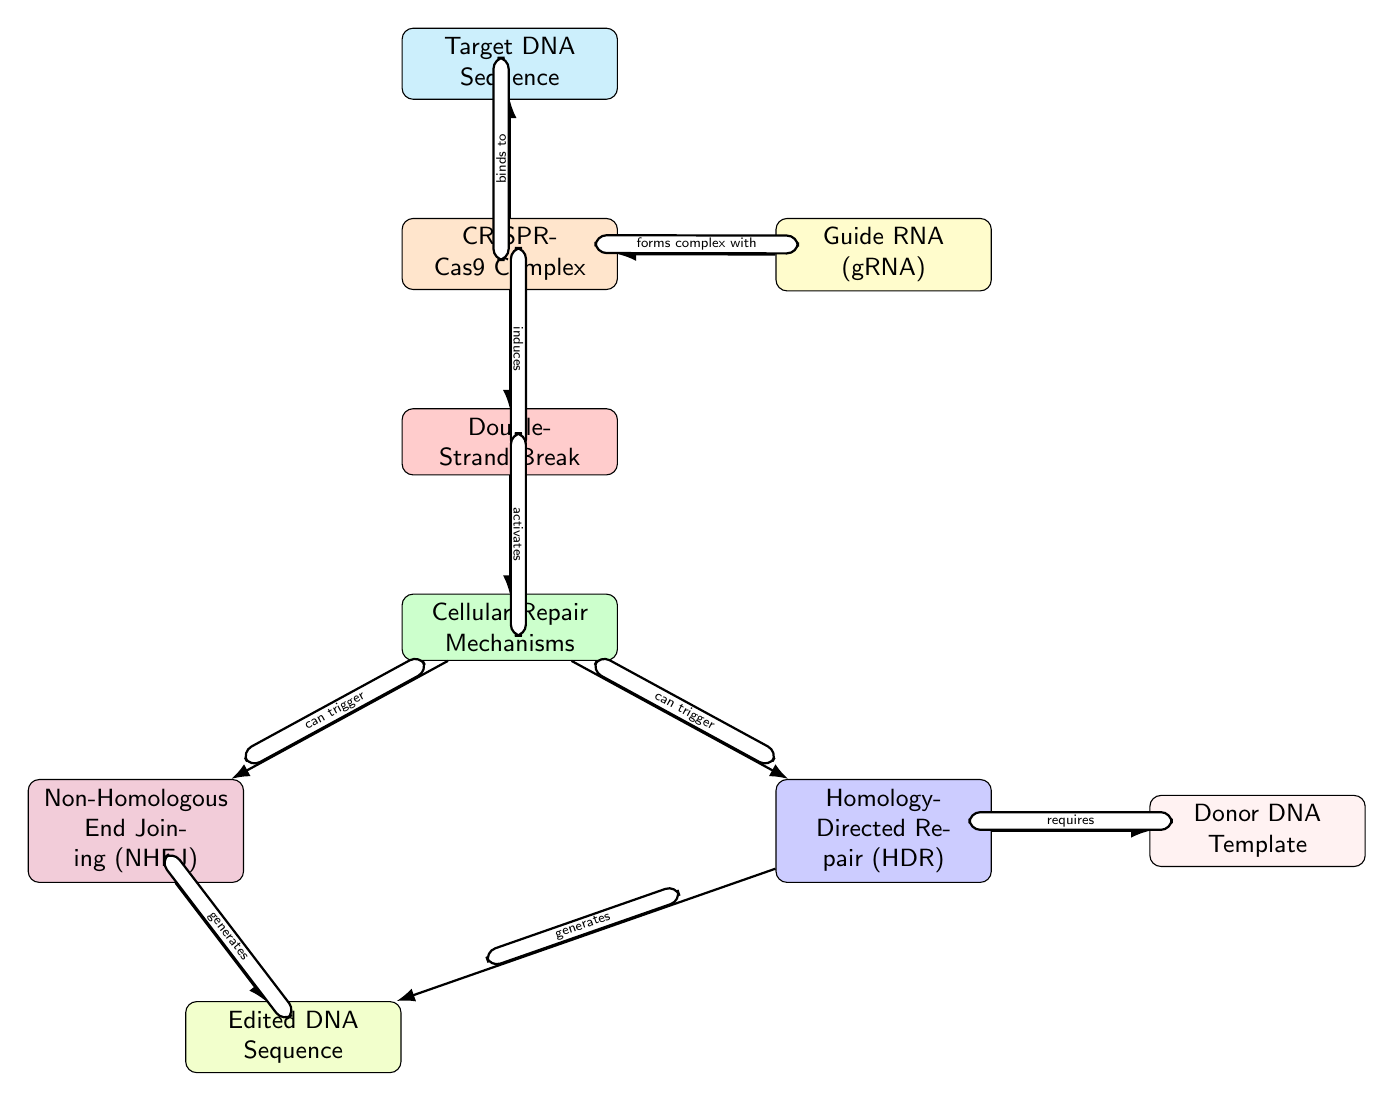What is the first step in the CRISPR-Cas9 mechanism? The first step is the identification of the Target DNA Sequence, which is indicated at the top of the diagram.
Answer: Target DNA Sequence What color represents the Double-Strand Break? The Double-Strand Break node is colored red, as specified in the diagram's color coding for different elements.
Answer: Red How many cellular repair mechanisms are listed in the diagram? There are two cellular repair mechanisms shown: Non-Homologous End Joining (NHEJ) and Homology-Directed Repair (HDR), which are positioned beneath the Cellular Repair Mechanisms node.
Answer: 2 What does the CRISPR-Cas9 Complex do to the Target DNA Sequence? The CRISPR-Cas9 Complex binds to the Target DNA Sequence, as indicated by the labeled edge between these two nodes.
Answer: Binds to What is required for Homology-Directed Repair? The diagram shows that Homology-Directed Repair requires a Donor DNA Template, which is connected with a directed edge labeled "requires."
Answer: Donor DNA Template What happens after the Double-Strand Break is induced? The Double-Strand Break activates Cellular Repair Mechanisms, reflecting the process flow from one node to the next.
Answer: Activates Which repair mechanism generates the Edited DNA Sequence? Both Non-Homologous End Joining (NHEJ) and Homology-Directed Repair (HDR) generate the Edited DNA Sequence, as indicated by the edges leading to that node.
Answer: Both (NHEJ and HDR) How does the Guide RNA contribute to the CRISPR-Cas9 Complex? The Guide RNA forms a complex with the CRISPR-Cas9 Complex, linking these two nodes in the diagram.
Answer: Forms complex with What is the last step shown in the CRISPR-Cas9 mechanism? The last step is generating the Edited DNA Sequence from either repair mechanism, as visually depicted at the bottom of the diagram.
Answer: Edited DNA Sequence 